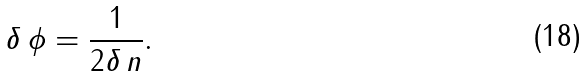Convert formula to latex. <formula><loc_0><loc_0><loc_500><loc_500>\delta \, \phi = \frac { 1 } { 2 \delta \, n } .</formula> 